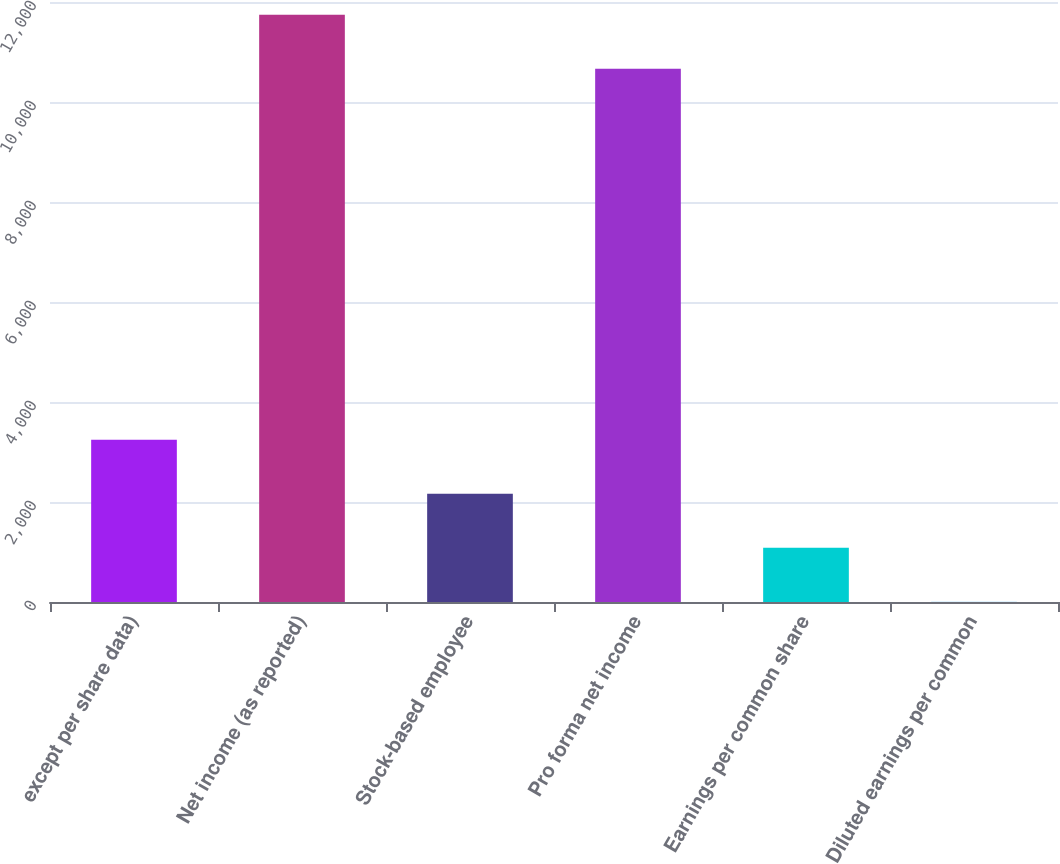Convert chart to OTSL. <chart><loc_0><loc_0><loc_500><loc_500><bar_chart><fcel>except per share data)<fcel>Net income (as reported)<fcel>Stock-based employee<fcel>Pro forma net income<fcel>Earnings per common share<fcel>Diluted earnings per common<nl><fcel>3245.49<fcel>11743.6<fcel>2164.85<fcel>10663<fcel>1084.21<fcel>3.57<nl></chart> 